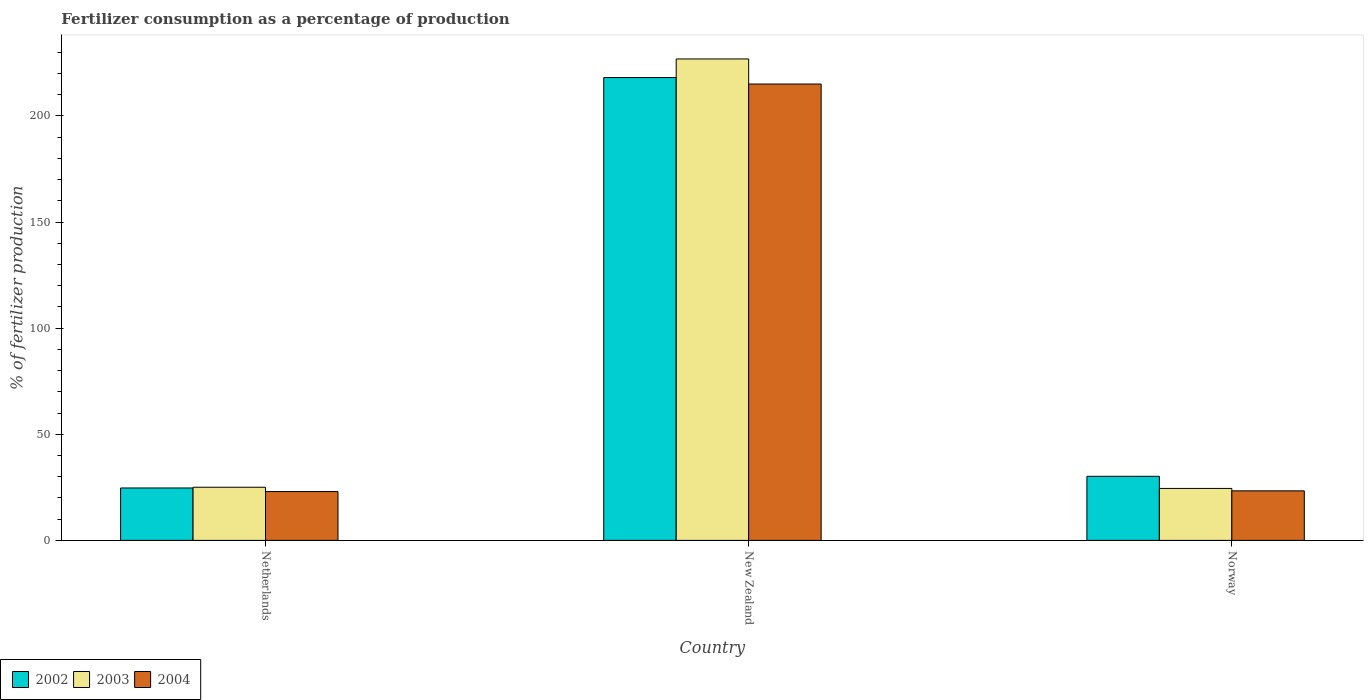How many different coloured bars are there?
Your answer should be compact. 3. What is the label of the 1st group of bars from the left?
Keep it short and to the point. Netherlands. What is the percentage of fertilizers consumed in 2004 in Norway?
Give a very brief answer. 23.34. Across all countries, what is the maximum percentage of fertilizers consumed in 2004?
Make the answer very short. 215.02. Across all countries, what is the minimum percentage of fertilizers consumed in 2004?
Provide a succinct answer. 23.01. In which country was the percentage of fertilizers consumed in 2002 maximum?
Offer a terse response. New Zealand. What is the total percentage of fertilizers consumed in 2003 in the graph?
Ensure brevity in your answer.  276.36. What is the difference between the percentage of fertilizers consumed in 2003 in New Zealand and that in Norway?
Keep it short and to the point. 202.35. What is the difference between the percentage of fertilizers consumed in 2004 in New Zealand and the percentage of fertilizers consumed in 2003 in Netherlands?
Offer a very short reply. 189.98. What is the average percentage of fertilizers consumed in 2003 per country?
Keep it short and to the point. 92.12. What is the difference between the percentage of fertilizers consumed of/in 2004 and percentage of fertilizers consumed of/in 2003 in Norway?
Your answer should be compact. -1.14. In how many countries, is the percentage of fertilizers consumed in 2004 greater than 220 %?
Offer a terse response. 0. What is the ratio of the percentage of fertilizers consumed in 2002 in Netherlands to that in New Zealand?
Provide a short and direct response. 0.11. Is the percentage of fertilizers consumed in 2004 in Netherlands less than that in New Zealand?
Your answer should be very brief. Yes. What is the difference between the highest and the second highest percentage of fertilizers consumed in 2003?
Offer a terse response. -0.56. What is the difference between the highest and the lowest percentage of fertilizers consumed in 2003?
Ensure brevity in your answer.  202.35. In how many countries, is the percentage of fertilizers consumed in 2003 greater than the average percentage of fertilizers consumed in 2003 taken over all countries?
Keep it short and to the point. 1. Is the sum of the percentage of fertilizers consumed in 2003 in Netherlands and Norway greater than the maximum percentage of fertilizers consumed in 2004 across all countries?
Offer a terse response. No. What does the 2nd bar from the left in Netherlands represents?
Ensure brevity in your answer.  2003. What does the 3rd bar from the right in Netherlands represents?
Your answer should be compact. 2002. How many bars are there?
Keep it short and to the point. 9. Are the values on the major ticks of Y-axis written in scientific E-notation?
Provide a short and direct response. No. Does the graph contain any zero values?
Provide a short and direct response. No. Where does the legend appear in the graph?
Your answer should be compact. Bottom left. How many legend labels are there?
Your answer should be compact. 3. What is the title of the graph?
Provide a succinct answer. Fertilizer consumption as a percentage of production. What is the label or title of the Y-axis?
Make the answer very short. % of fertilizer production. What is the % of fertilizer production in 2002 in Netherlands?
Offer a terse response. 24.7. What is the % of fertilizer production in 2003 in Netherlands?
Your answer should be compact. 25.04. What is the % of fertilizer production of 2004 in Netherlands?
Offer a very short reply. 23.01. What is the % of fertilizer production in 2002 in New Zealand?
Offer a very short reply. 218.08. What is the % of fertilizer production of 2003 in New Zealand?
Offer a terse response. 226.83. What is the % of fertilizer production in 2004 in New Zealand?
Provide a succinct answer. 215.02. What is the % of fertilizer production in 2002 in Norway?
Your answer should be very brief. 30.19. What is the % of fertilizer production in 2003 in Norway?
Offer a very short reply. 24.48. What is the % of fertilizer production of 2004 in Norway?
Your response must be concise. 23.34. Across all countries, what is the maximum % of fertilizer production of 2002?
Offer a terse response. 218.08. Across all countries, what is the maximum % of fertilizer production in 2003?
Offer a terse response. 226.83. Across all countries, what is the maximum % of fertilizer production in 2004?
Provide a succinct answer. 215.02. Across all countries, what is the minimum % of fertilizer production of 2002?
Your response must be concise. 24.7. Across all countries, what is the minimum % of fertilizer production of 2003?
Your answer should be very brief. 24.48. Across all countries, what is the minimum % of fertilizer production in 2004?
Your response must be concise. 23.01. What is the total % of fertilizer production in 2002 in the graph?
Offer a terse response. 272.96. What is the total % of fertilizer production of 2003 in the graph?
Provide a succinct answer. 276.36. What is the total % of fertilizer production in 2004 in the graph?
Your response must be concise. 261.37. What is the difference between the % of fertilizer production in 2002 in Netherlands and that in New Zealand?
Give a very brief answer. -193.38. What is the difference between the % of fertilizer production of 2003 in Netherlands and that in New Zealand?
Ensure brevity in your answer.  -201.79. What is the difference between the % of fertilizer production of 2004 in Netherlands and that in New Zealand?
Provide a succinct answer. -192.01. What is the difference between the % of fertilizer production in 2002 in Netherlands and that in Norway?
Give a very brief answer. -5.5. What is the difference between the % of fertilizer production in 2003 in Netherlands and that in Norway?
Your answer should be compact. 0.56. What is the difference between the % of fertilizer production of 2004 in Netherlands and that in Norway?
Provide a short and direct response. -0.34. What is the difference between the % of fertilizer production in 2002 in New Zealand and that in Norway?
Offer a terse response. 187.88. What is the difference between the % of fertilizer production of 2003 in New Zealand and that in Norway?
Make the answer very short. 202.35. What is the difference between the % of fertilizer production in 2004 in New Zealand and that in Norway?
Your response must be concise. 191.68. What is the difference between the % of fertilizer production in 2002 in Netherlands and the % of fertilizer production in 2003 in New Zealand?
Provide a succinct answer. -202.14. What is the difference between the % of fertilizer production of 2002 in Netherlands and the % of fertilizer production of 2004 in New Zealand?
Your answer should be compact. -190.33. What is the difference between the % of fertilizer production in 2003 in Netherlands and the % of fertilizer production in 2004 in New Zealand?
Keep it short and to the point. -189.98. What is the difference between the % of fertilizer production in 2002 in Netherlands and the % of fertilizer production in 2003 in Norway?
Offer a terse response. 0.21. What is the difference between the % of fertilizer production of 2002 in Netherlands and the % of fertilizer production of 2004 in Norway?
Keep it short and to the point. 1.35. What is the difference between the % of fertilizer production in 2003 in Netherlands and the % of fertilizer production in 2004 in Norway?
Offer a very short reply. 1.7. What is the difference between the % of fertilizer production of 2002 in New Zealand and the % of fertilizer production of 2003 in Norway?
Keep it short and to the point. 193.59. What is the difference between the % of fertilizer production in 2002 in New Zealand and the % of fertilizer production in 2004 in Norway?
Offer a terse response. 194.73. What is the difference between the % of fertilizer production in 2003 in New Zealand and the % of fertilizer production in 2004 in Norway?
Make the answer very short. 203.49. What is the average % of fertilizer production in 2002 per country?
Provide a short and direct response. 90.99. What is the average % of fertilizer production in 2003 per country?
Offer a very short reply. 92.12. What is the average % of fertilizer production in 2004 per country?
Your answer should be compact. 87.12. What is the difference between the % of fertilizer production in 2002 and % of fertilizer production in 2003 in Netherlands?
Ensure brevity in your answer.  -0.35. What is the difference between the % of fertilizer production in 2002 and % of fertilizer production in 2004 in Netherlands?
Ensure brevity in your answer.  1.69. What is the difference between the % of fertilizer production of 2003 and % of fertilizer production of 2004 in Netherlands?
Provide a succinct answer. 2.04. What is the difference between the % of fertilizer production of 2002 and % of fertilizer production of 2003 in New Zealand?
Keep it short and to the point. -8.76. What is the difference between the % of fertilizer production in 2002 and % of fertilizer production in 2004 in New Zealand?
Your answer should be very brief. 3.05. What is the difference between the % of fertilizer production of 2003 and % of fertilizer production of 2004 in New Zealand?
Provide a short and direct response. 11.81. What is the difference between the % of fertilizer production in 2002 and % of fertilizer production in 2003 in Norway?
Make the answer very short. 5.71. What is the difference between the % of fertilizer production of 2002 and % of fertilizer production of 2004 in Norway?
Provide a short and direct response. 6.85. What is the difference between the % of fertilizer production in 2003 and % of fertilizer production in 2004 in Norway?
Offer a very short reply. 1.14. What is the ratio of the % of fertilizer production of 2002 in Netherlands to that in New Zealand?
Give a very brief answer. 0.11. What is the ratio of the % of fertilizer production of 2003 in Netherlands to that in New Zealand?
Your response must be concise. 0.11. What is the ratio of the % of fertilizer production in 2004 in Netherlands to that in New Zealand?
Keep it short and to the point. 0.11. What is the ratio of the % of fertilizer production in 2002 in Netherlands to that in Norway?
Provide a succinct answer. 0.82. What is the ratio of the % of fertilizer production in 2003 in Netherlands to that in Norway?
Offer a very short reply. 1.02. What is the ratio of the % of fertilizer production of 2004 in Netherlands to that in Norway?
Give a very brief answer. 0.99. What is the ratio of the % of fertilizer production in 2002 in New Zealand to that in Norway?
Give a very brief answer. 7.22. What is the ratio of the % of fertilizer production of 2003 in New Zealand to that in Norway?
Offer a very short reply. 9.26. What is the ratio of the % of fertilizer production in 2004 in New Zealand to that in Norway?
Make the answer very short. 9.21. What is the difference between the highest and the second highest % of fertilizer production in 2002?
Make the answer very short. 187.88. What is the difference between the highest and the second highest % of fertilizer production in 2003?
Provide a succinct answer. 201.79. What is the difference between the highest and the second highest % of fertilizer production of 2004?
Your answer should be very brief. 191.68. What is the difference between the highest and the lowest % of fertilizer production of 2002?
Provide a short and direct response. 193.38. What is the difference between the highest and the lowest % of fertilizer production of 2003?
Give a very brief answer. 202.35. What is the difference between the highest and the lowest % of fertilizer production in 2004?
Offer a terse response. 192.01. 